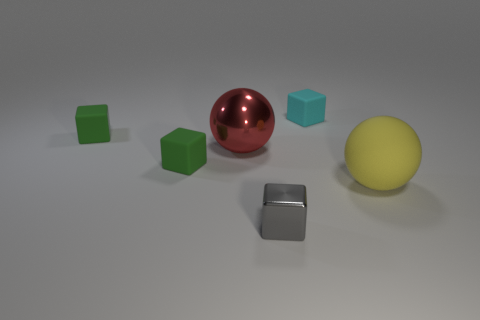Add 1 red rubber cubes. How many objects exist? 7 Subtract all spheres. How many objects are left? 4 Subtract all small cyan rubber things. Subtract all small green things. How many objects are left? 3 Add 4 balls. How many balls are left? 6 Add 6 shiny cubes. How many shiny cubes exist? 7 Subtract 0 red cylinders. How many objects are left? 6 